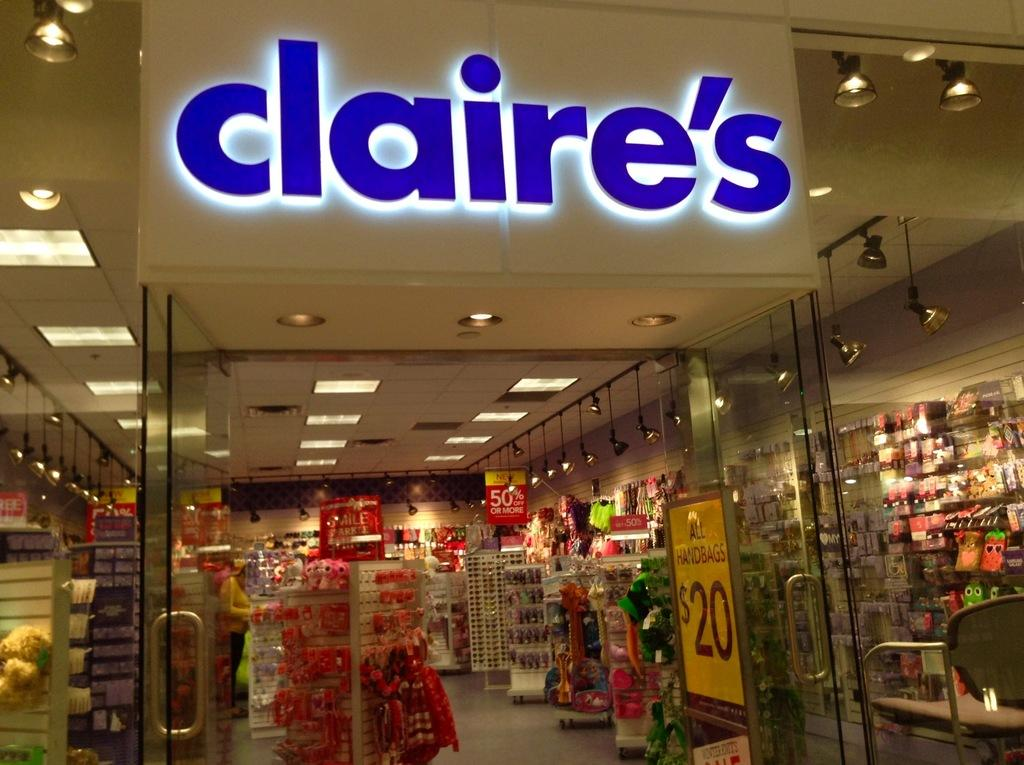<image>
Create a compact narrative representing the image presented. A store front in a mall for the retailer Claire's. 